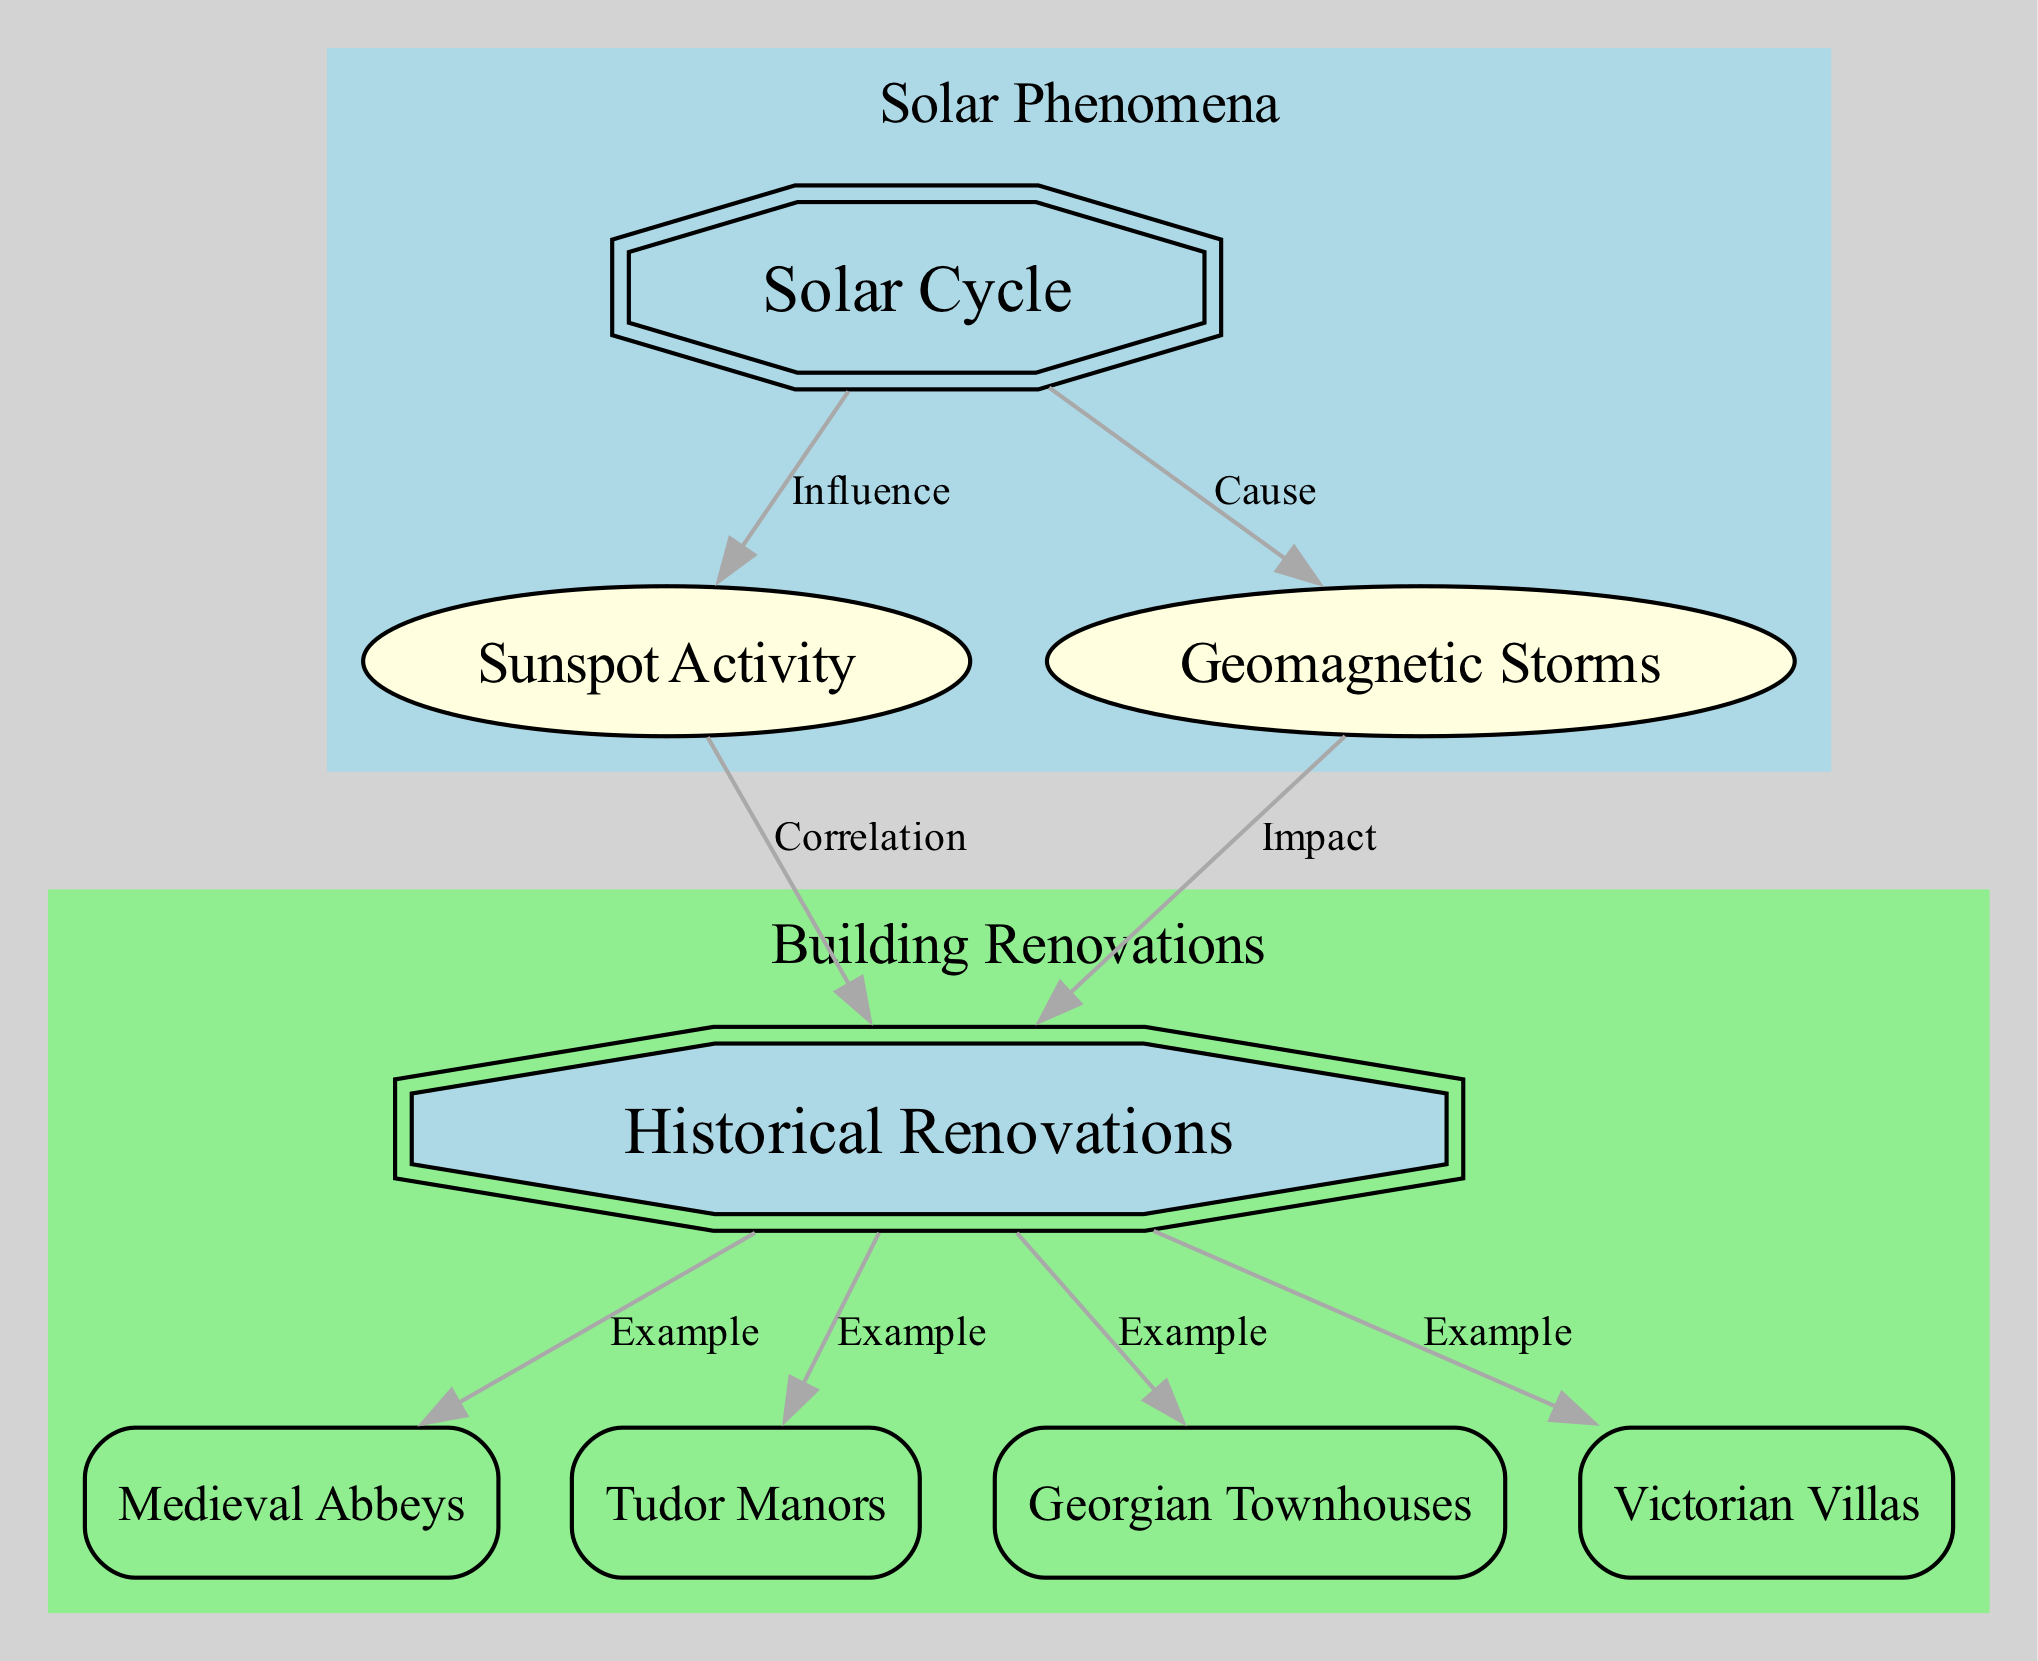What is the central node of the diagram? The central node is the main focus of the diagram, which can be identified as it is typically highlighted or emphasizes a key concept. In this case, the node labelled "Solar Cycle" is placed prominently at the center.
Answer: Solar Cycle How many example nodes are present in the diagram? To determine the number of example nodes, we can count the nodes whose type is labeled as "example". The nodes are "medieval_abbeys", "tudor_manors", "georgian_townhouses", and "victorian_villas", amounting to four.
Answer: 4 What type of relationship exists between "solar_cycle" and "sunspot_activity"? By reviewing the connections in the diagram, we can find that "solar_cycle" has an edge leading to "sunspot_activity", labelled "Influence". This indicates a descriptive relationship, establishing that the solar cycle has an influence on sunspot activity.
Answer: Influence Which node is connected to both "sunspot_activity" and "geomagnetic_storms"? To find the node connected to both "sunspot_activity" and "geomagnetic_storms", we look for the central node "historical_renovations", which is connected to both by edges labelled "Correlation" and "Impact".
Answer: historical_renovations What is the impact of geomagnetic storms on historical renovations? The edges in the diagram indicate the relationships whereby "geomagnetic_storms" impacts "historical_renovations", suggesting that in periods of increased geomagnetic storms, there might be a notable effect on renovation activities in historical buildings. This is reflected in the label connecting these nodes.
Answer: Impact How many edges are connected to the node "historical_renovations"? By visually inspecting the diagram, we can see that "historical_renovations" has four outgoing edges, linking it to the example nodes: "medieval_abbeys", "tudor_manors", "georgian_townhouses", and "victorian_villas". Counting these edges gives us a totals of four.
Answer: 4 What are the two attributes of the solar cycle represented in the diagram? The attributes connected to the central node "solar_cycle" are visible; "sunspot_activity" and "geomagnetic_storms". These are key aspects of the solar phenomena being examined in relation to historical building renovations.
Answer: Sunspot Activity, Geomagnetic Storms Which building type is NOT an example of historical renovations in the diagram? Since the diagram lists specific examples of historical renovations as "medieval_abbeys", "tudor_manors", "georgian_townhouses", and "victorian_villas", therefore any building type not listed among these four is not considered. For this case, one might consider other potential building types in Suffolk that were not represented, such as "modern structures."
Answer: Modern Structures 